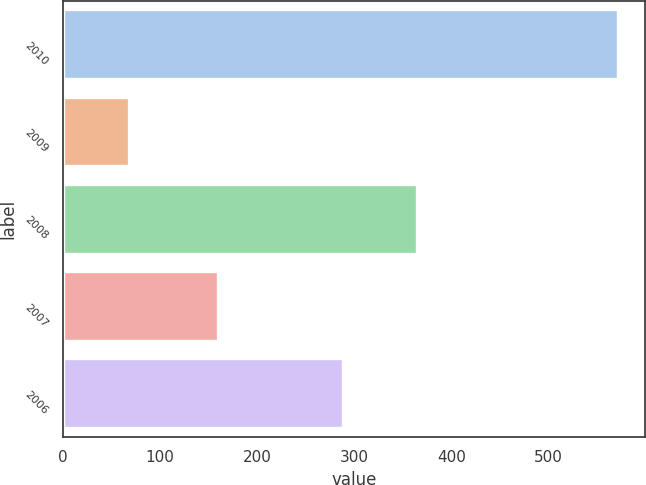<chart> <loc_0><loc_0><loc_500><loc_500><bar_chart><fcel>2010<fcel>2009<fcel>2008<fcel>2007<fcel>2006<nl><fcel>571.1<fcel>67.4<fcel>364.3<fcel>160<fcel>287.9<nl></chart> 